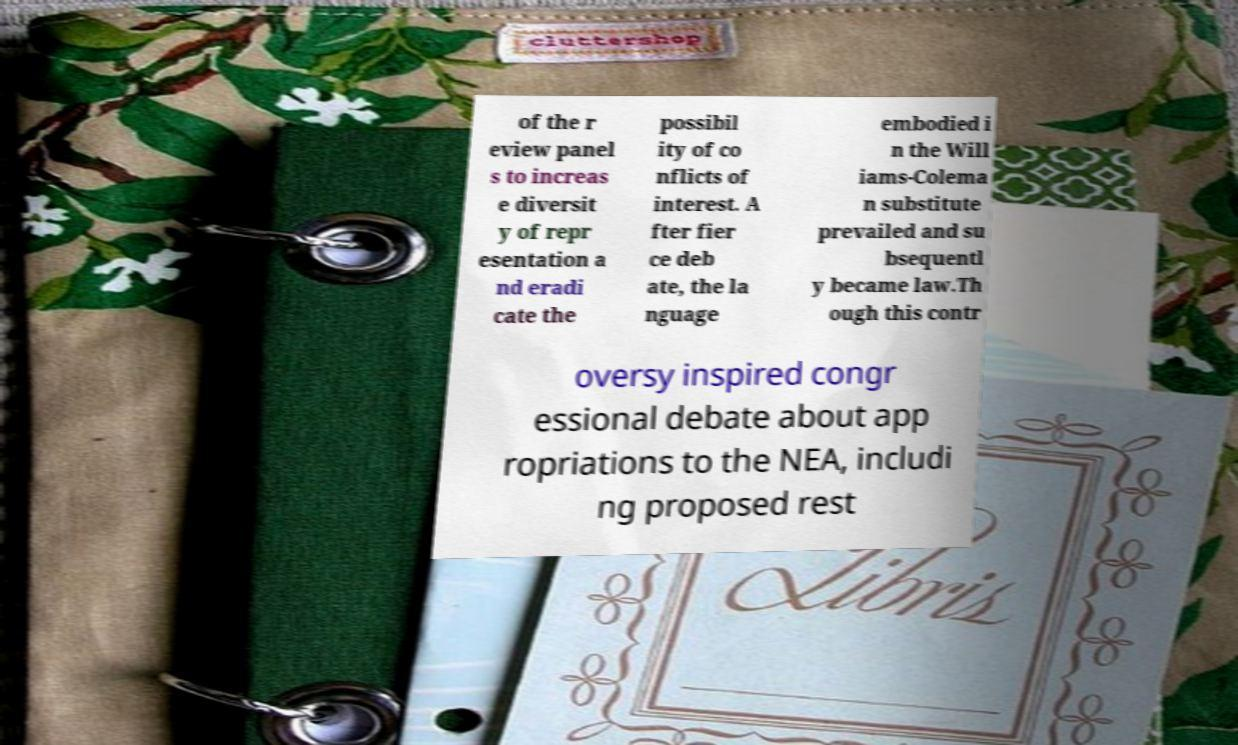Can you accurately transcribe the text from the provided image for me? of the r eview panel s to increas e diversit y of repr esentation a nd eradi cate the possibil ity of co nflicts of interest. A fter fier ce deb ate, the la nguage embodied i n the Will iams-Colema n substitute prevailed and su bsequentl y became law.Th ough this contr oversy inspired congr essional debate about app ropriations to the NEA, includi ng proposed rest 